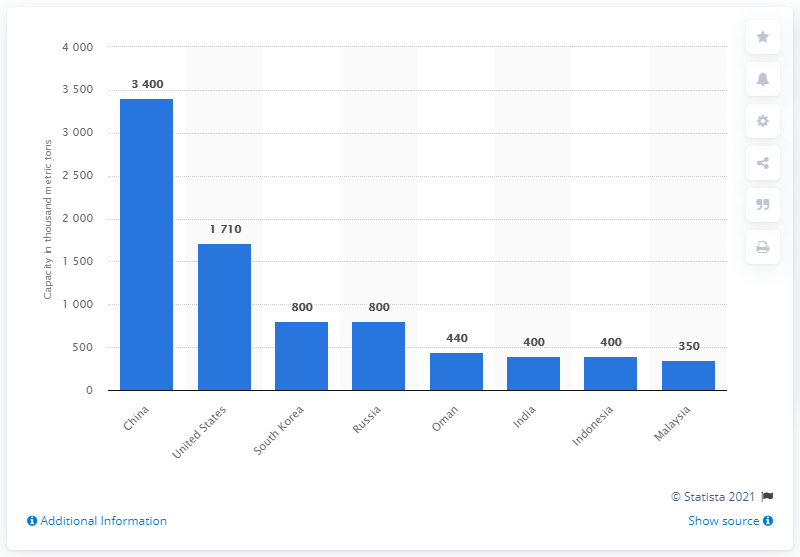Outline some significant characteristics in this image. The country with the largest new production capacity of linear low-density polyethylene is China. 